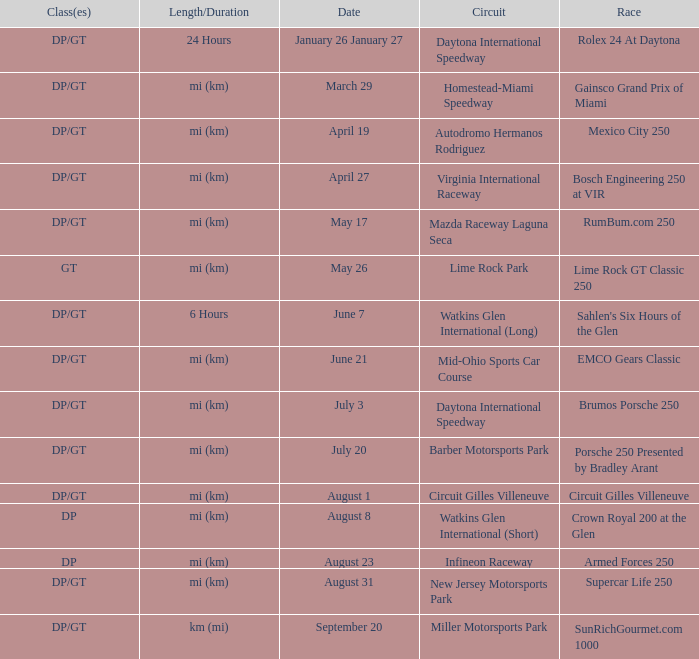What was the date of the race that lasted 6 hours? June 7. 